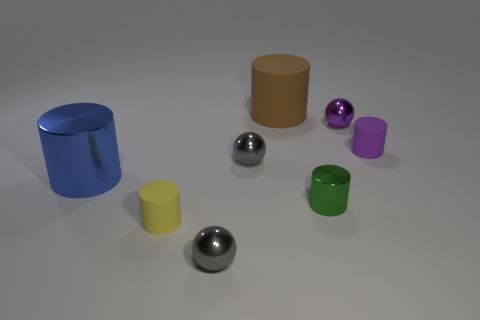Subtract all small purple balls. How many balls are left? 2 Add 1 purple metallic objects. How many objects exist? 9 Subtract all brown cylinders. How many cylinders are left? 4 Subtract all cylinders. How many objects are left? 3 Subtract 1 brown cylinders. How many objects are left? 7 Subtract 2 spheres. How many spheres are left? 1 Subtract all red cylinders. Subtract all gray balls. How many cylinders are left? 5 Subtract all green cubes. How many red cylinders are left? 0 Subtract all gray spheres. Subtract all big blue shiny things. How many objects are left? 5 Add 4 green cylinders. How many green cylinders are left? 5 